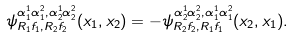<formula> <loc_0><loc_0><loc_500><loc_500>\psi _ { R _ { 1 } f _ { 1 } , R _ { 2 } f _ { 2 } } ^ { \alpha _ { 1 } ^ { 1 } \alpha _ { 1 } ^ { 2 } , \alpha _ { 2 } ^ { 1 } \alpha _ { 2 } ^ { 2 } } ( x _ { 1 } , x _ { 2 } ) = - \psi _ { R _ { 2 } f _ { 2 } , R _ { 1 } f _ { 1 } } ^ { \alpha _ { 2 } ^ { 1 } \alpha _ { 2 } ^ { 2 } , \alpha _ { 1 } ^ { 1 } \alpha _ { 1 } ^ { 2 } } ( x _ { 2 } , x _ { 1 } ) .</formula> 